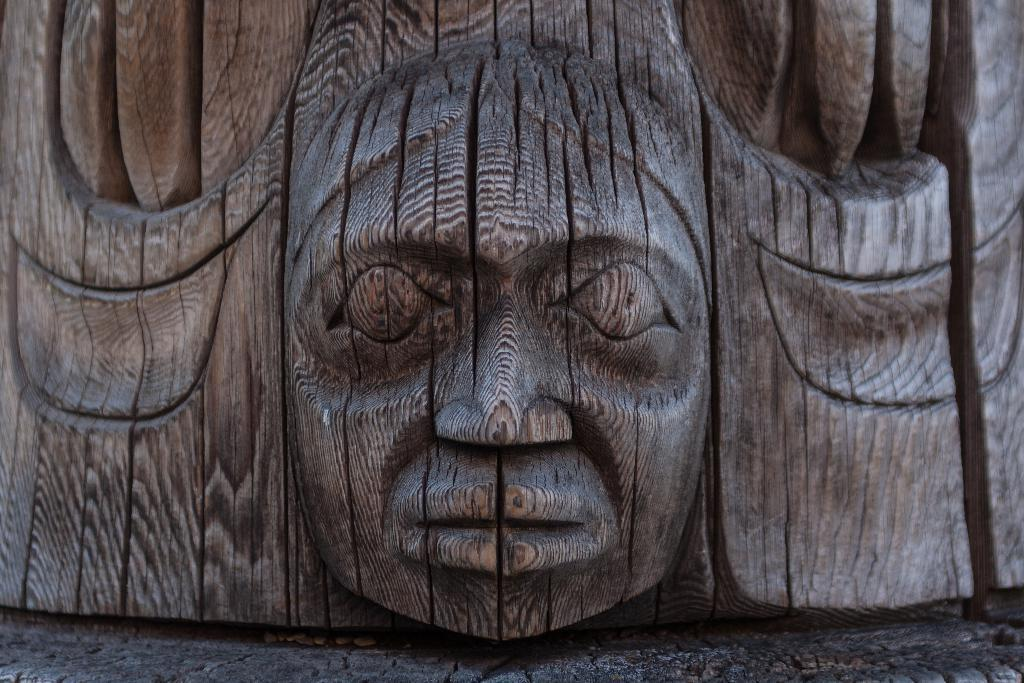What type of artwork is depicted in the image? There is carving on wood in the image. What is visible at the bottom of the image? There is a floor visible at the bottom of the image. What type of drug is being used by the stranger in the image? There is no stranger or drug present in the image; it features carving on wood and a floor. 